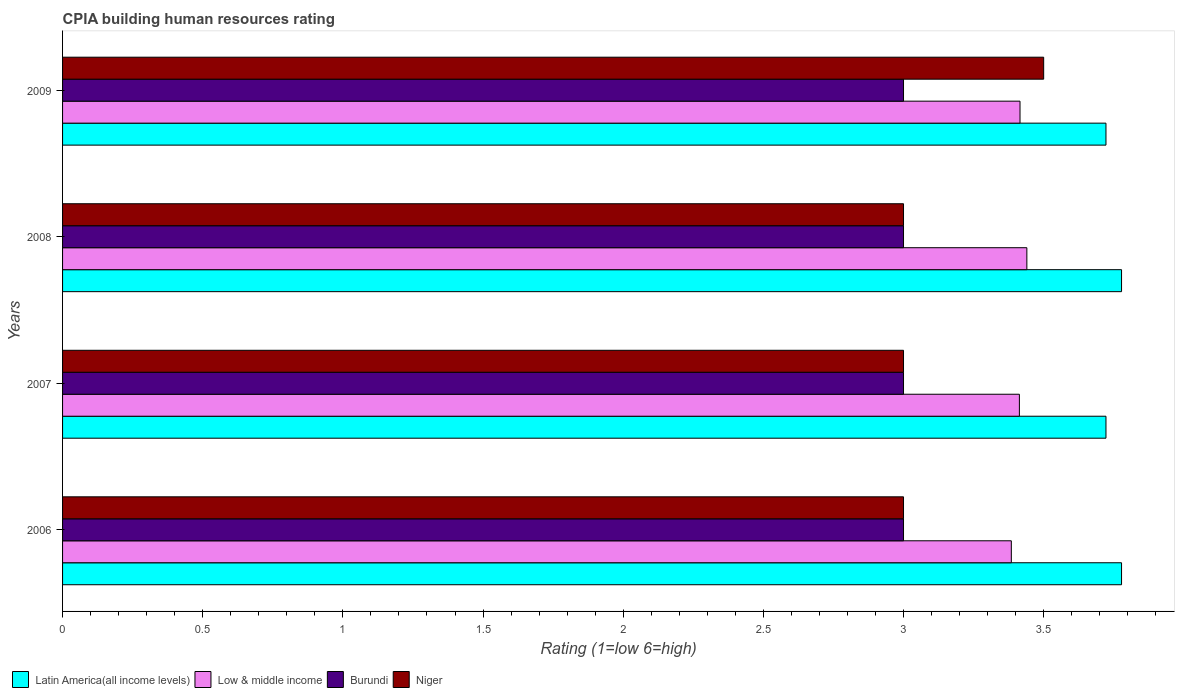Are the number of bars per tick equal to the number of legend labels?
Keep it short and to the point. Yes. What is the CPIA rating in Latin America(all income levels) in 2008?
Keep it short and to the point. 3.78. Across all years, what is the maximum CPIA rating in Low & middle income?
Provide a short and direct response. 3.44. Across all years, what is the minimum CPIA rating in Niger?
Your answer should be very brief. 3. What is the total CPIA rating in Burundi in the graph?
Offer a very short reply. 12. What is the difference between the CPIA rating in Burundi in 2006 and that in 2007?
Your answer should be very brief. 0. What is the difference between the CPIA rating in Burundi in 2006 and the CPIA rating in Low & middle income in 2007?
Keep it short and to the point. -0.41. What is the average CPIA rating in Low & middle income per year?
Give a very brief answer. 3.41. In the year 2009, what is the difference between the CPIA rating in Niger and CPIA rating in Latin America(all income levels)?
Provide a short and direct response. -0.22. In how many years, is the CPIA rating in Low & middle income greater than 0.2 ?
Make the answer very short. 4. What is the ratio of the CPIA rating in Burundi in 2006 to that in 2009?
Ensure brevity in your answer.  1. Is the CPIA rating in Latin America(all income levels) in 2007 less than that in 2009?
Your response must be concise. No. What is the difference between the highest and the second highest CPIA rating in Low & middle income?
Offer a terse response. 0.02. In how many years, is the CPIA rating in Latin America(all income levels) greater than the average CPIA rating in Latin America(all income levels) taken over all years?
Your answer should be very brief. 2. Is it the case that in every year, the sum of the CPIA rating in Latin America(all income levels) and CPIA rating in Burundi is greater than the sum of CPIA rating in Niger and CPIA rating in Low & middle income?
Your answer should be very brief. No. What does the 2nd bar from the top in 2009 represents?
Offer a terse response. Burundi. What does the 3rd bar from the bottom in 2008 represents?
Offer a terse response. Burundi. Is it the case that in every year, the sum of the CPIA rating in Latin America(all income levels) and CPIA rating in Low & middle income is greater than the CPIA rating in Niger?
Provide a succinct answer. Yes. How many bars are there?
Make the answer very short. 16. Are all the bars in the graph horizontal?
Offer a very short reply. Yes. What is the difference between two consecutive major ticks on the X-axis?
Ensure brevity in your answer.  0.5. Does the graph contain any zero values?
Keep it short and to the point. No. How many legend labels are there?
Offer a terse response. 4. How are the legend labels stacked?
Give a very brief answer. Horizontal. What is the title of the graph?
Give a very brief answer. CPIA building human resources rating. What is the label or title of the Y-axis?
Provide a short and direct response. Years. What is the Rating (1=low 6=high) of Latin America(all income levels) in 2006?
Provide a short and direct response. 3.78. What is the Rating (1=low 6=high) of Low & middle income in 2006?
Your answer should be compact. 3.38. What is the Rating (1=low 6=high) of Latin America(all income levels) in 2007?
Offer a terse response. 3.72. What is the Rating (1=low 6=high) of Low & middle income in 2007?
Provide a succinct answer. 3.41. What is the Rating (1=low 6=high) of Burundi in 2007?
Your answer should be compact. 3. What is the Rating (1=low 6=high) in Latin America(all income levels) in 2008?
Offer a very short reply. 3.78. What is the Rating (1=low 6=high) in Low & middle income in 2008?
Give a very brief answer. 3.44. What is the Rating (1=low 6=high) in Niger in 2008?
Your answer should be compact. 3. What is the Rating (1=low 6=high) of Latin America(all income levels) in 2009?
Offer a very short reply. 3.72. What is the Rating (1=low 6=high) of Low & middle income in 2009?
Ensure brevity in your answer.  3.42. What is the Rating (1=low 6=high) of Burundi in 2009?
Offer a terse response. 3. Across all years, what is the maximum Rating (1=low 6=high) of Latin America(all income levels)?
Offer a very short reply. 3.78. Across all years, what is the maximum Rating (1=low 6=high) of Low & middle income?
Your answer should be very brief. 3.44. Across all years, what is the maximum Rating (1=low 6=high) in Burundi?
Make the answer very short. 3. Across all years, what is the maximum Rating (1=low 6=high) of Niger?
Offer a very short reply. 3.5. Across all years, what is the minimum Rating (1=low 6=high) in Latin America(all income levels)?
Provide a short and direct response. 3.72. Across all years, what is the minimum Rating (1=low 6=high) in Low & middle income?
Offer a terse response. 3.38. Across all years, what is the minimum Rating (1=low 6=high) of Burundi?
Provide a succinct answer. 3. Across all years, what is the minimum Rating (1=low 6=high) in Niger?
Make the answer very short. 3. What is the total Rating (1=low 6=high) in Low & middle income in the graph?
Provide a short and direct response. 13.65. What is the total Rating (1=low 6=high) in Burundi in the graph?
Offer a very short reply. 12. What is the total Rating (1=low 6=high) of Niger in the graph?
Give a very brief answer. 12.5. What is the difference between the Rating (1=low 6=high) in Latin America(all income levels) in 2006 and that in 2007?
Provide a short and direct response. 0.06. What is the difference between the Rating (1=low 6=high) of Low & middle income in 2006 and that in 2007?
Your answer should be very brief. -0.03. What is the difference between the Rating (1=low 6=high) of Burundi in 2006 and that in 2007?
Ensure brevity in your answer.  0. What is the difference between the Rating (1=low 6=high) in Latin America(all income levels) in 2006 and that in 2008?
Your answer should be compact. 0. What is the difference between the Rating (1=low 6=high) in Low & middle income in 2006 and that in 2008?
Provide a succinct answer. -0.06. What is the difference between the Rating (1=low 6=high) in Burundi in 2006 and that in 2008?
Offer a very short reply. 0. What is the difference between the Rating (1=low 6=high) of Niger in 2006 and that in 2008?
Give a very brief answer. 0. What is the difference between the Rating (1=low 6=high) of Latin America(all income levels) in 2006 and that in 2009?
Offer a very short reply. 0.06. What is the difference between the Rating (1=low 6=high) of Low & middle income in 2006 and that in 2009?
Keep it short and to the point. -0.03. What is the difference between the Rating (1=low 6=high) of Burundi in 2006 and that in 2009?
Ensure brevity in your answer.  0. What is the difference between the Rating (1=low 6=high) in Latin America(all income levels) in 2007 and that in 2008?
Your response must be concise. -0.06. What is the difference between the Rating (1=low 6=high) in Low & middle income in 2007 and that in 2008?
Provide a succinct answer. -0.03. What is the difference between the Rating (1=low 6=high) of Niger in 2007 and that in 2008?
Ensure brevity in your answer.  0. What is the difference between the Rating (1=low 6=high) in Latin America(all income levels) in 2007 and that in 2009?
Provide a succinct answer. 0. What is the difference between the Rating (1=low 6=high) of Low & middle income in 2007 and that in 2009?
Your response must be concise. -0. What is the difference between the Rating (1=low 6=high) of Niger in 2007 and that in 2009?
Offer a terse response. -0.5. What is the difference between the Rating (1=low 6=high) in Latin America(all income levels) in 2008 and that in 2009?
Provide a succinct answer. 0.06. What is the difference between the Rating (1=low 6=high) of Low & middle income in 2008 and that in 2009?
Your response must be concise. 0.02. What is the difference between the Rating (1=low 6=high) of Latin America(all income levels) in 2006 and the Rating (1=low 6=high) of Low & middle income in 2007?
Give a very brief answer. 0.36. What is the difference between the Rating (1=low 6=high) in Latin America(all income levels) in 2006 and the Rating (1=low 6=high) in Burundi in 2007?
Ensure brevity in your answer.  0.78. What is the difference between the Rating (1=low 6=high) in Low & middle income in 2006 and the Rating (1=low 6=high) in Burundi in 2007?
Provide a succinct answer. 0.38. What is the difference between the Rating (1=low 6=high) in Low & middle income in 2006 and the Rating (1=low 6=high) in Niger in 2007?
Your answer should be very brief. 0.38. What is the difference between the Rating (1=low 6=high) of Burundi in 2006 and the Rating (1=low 6=high) of Niger in 2007?
Ensure brevity in your answer.  0. What is the difference between the Rating (1=low 6=high) of Latin America(all income levels) in 2006 and the Rating (1=low 6=high) of Low & middle income in 2008?
Ensure brevity in your answer.  0.34. What is the difference between the Rating (1=low 6=high) of Low & middle income in 2006 and the Rating (1=low 6=high) of Burundi in 2008?
Provide a succinct answer. 0.38. What is the difference between the Rating (1=low 6=high) of Low & middle income in 2006 and the Rating (1=low 6=high) of Niger in 2008?
Your answer should be very brief. 0.38. What is the difference between the Rating (1=low 6=high) in Burundi in 2006 and the Rating (1=low 6=high) in Niger in 2008?
Provide a succinct answer. 0. What is the difference between the Rating (1=low 6=high) in Latin America(all income levels) in 2006 and the Rating (1=low 6=high) in Low & middle income in 2009?
Ensure brevity in your answer.  0.36. What is the difference between the Rating (1=low 6=high) in Latin America(all income levels) in 2006 and the Rating (1=low 6=high) in Burundi in 2009?
Your answer should be very brief. 0.78. What is the difference between the Rating (1=low 6=high) of Latin America(all income levels) in 2006 and the Rating (1=low 6=high) of Niger in 2009?
Provide a short and direct response. 0.28. What is the difference between the Rating (1=low 6=high) in Low & middle income in 2006 and the Rating (1=low 6=high) in Burundi in 2009?
Offer a very short reply. 0.38. What is the difference between the Rating (1=low 6=high) of Low & middle income in 2006 and the Rating (1=low 6=high) of Niger in 2009?
Give a very brief answer. -0.12. What is the difference between the Rating (1=low 6=high) in Latin America(all income levels) in 2007 and the Rating (1=low 6=high) in Low & middle income in 2008?
Your response must be concise. 0.28. What is the difference between the Rating (1=low 6=high) in Latin America(all income levels) in 2007 and the Rating (1=low 6=high) in Burundi in 2008?
Offer a terse response. 0.72. What is the difference between the Rating (1=low 6=high) of Latin America(all income levels) in 2007 and the Rating (1=low 6=high) of Niger in 2008?
Provide a short and direct response. 0.72. What is the difference between the Rating (1=low 6=high) of Low & middle income in 2007 and the Rating (1=low 6=high) of Burundi in 2008?
Keep it short and to the point. 0.41. What is the difference between the Rating (1=low 6=high) of Low & middle income in 2007 and the Rating (1=low 6=high) of Niger in 2008?
Offer a very short reply. 0.41. What is the difference between the Rating (1=low 6=high) of Latin America(all income levels) in 2007 and the Rating (1=low 6=high) of Low & middle income in 2009?
Provide a short and direct response. 0.31. What is the difference between the Rating (1=low 6=high) in Latin America(all income levels) in 2007 and the Rating (1=low 6=high) in Burundi in 2009?
Ensure brevity in your answer.  0.72. What is the difference between the Rating (1=low 6=high) of Latin America(all income levels) in 2007 and the Rating (1=low 6=high) of Niger in 2009?
Your answer should be compact. 0.22. What is the difference between the Rating (1=low 6=high) in Low & middle income in 2007 and the Rating (1=low 6=high) in Burundi in 2009?
Your answer should be very brief. 0.41. What is the difference between the Rating (1=low 6=high) in Low & middle income in 2007 and the Rating (1=low 6=high) in Niger in 2009?
Your response must be concise. -0.09. What is the difference between the Rating (1=low 6=high) of Burundi in 2007 and the Rating (1=low 6=high) of Niger in 2009?
Offer a very short reply. -0.5. What is the difference between the Rating (1=low 6=high) of Latin America(all income levels) in 2008 and the Rating (1=low 6=high) of Low & middle income in 2009?
Ensure brevity in your answer.  0.36. What is the difference between the Rating (1=low 6=high) in Latin America(all income levels) in 2008 and the Rating (1=low 6=high) in Burundi in 2009?
Ensure brevity in your answer.  0.78. What is the difference between the Rating (1=low 6=high) in Latin America(all income levels) in 2008 and the Rating (1=low 6=high) in Niger in 2009?
Keep it short and to the point. 0.28. What is the difference between the Rating (1=low 6=high) in Low & middle income in 2008 and the Rating (1=low 6=high) in Burundi in 2009?
Your response must be concise. 0.44. What is the difference between the Rating (1=low 6=high) in Low & middle income in 2008 and the Rating (1=low 6=high) in Niger in 2009?
Offer a very short reply. -0.06. What is the average Rating (1=low 6=high) in Latin America(all income levels) per year?
Ensure brevity in your answer.  3.75. What is the average Rating (1=low 6=high) of Low & middle income per year?
Your answer should be very brief. 3.41. What is the average Rating (1=low 6=high) of Niger per year?
Make the answer very short. 3.12. In the year 2006, what is the difference between the Rating (1=low 6=high) in Latin America(all income levels) and Rating (1=low 6=high) in Low & middle income?
Keep it short and to the point. 0.39. In the year 2006, what is the difference between the Rating (1=low 6=high) of Latin America(all income levels) and Rating (1=low 6=high) of Burundi?
Keep it short and to the point. 0.78. In the year 2006, what is the difference between the Rating (1=low 6=high) of Latin America(all income levels) and Rating (1=low 6=high) of Niger?
Ensure brevity in your answer.  0.78. In the year 2006, what is the difference between the Rating (1=low 6=high) of Low & middle income and Rating (1=low 6=high) of Burundi?
Offer a terse response. 0.38. In the year 2006, what is the difference between the Rating (1=low 6=high) in Low & middle income and Rating (1=low 6=high) in Niger?
Give a very brief answer. 0.38. In the year 2006, what is the difference between the Rating (1=low 6=high) of Burundi and Rating (1=low 6=high) of Niger?
Provide a short and direct response. 0. In the year 2007, what is the difference between the Rating (1=low 6=high) in Latin America(all income levels) and Rating (1=low 6=high) in Low & middle income?
Give a very brief answer. 0.31. In the year 2007, what is the difference between the Rating (1=low 6=high) in Latin America(all income levels) and Rating (1=low 6=high) in Burundi?
Offer a very short reply. 0.72. In the year 2007, what is the difference between the Rating (1=low 6=high) of Latin America(all income levels) and Rating (1=low 6=high) of Niger?
Your response must be concise. 0.72. In the year 2007, what is the difference between the Rating (1=low 6=high) of Low & middle income and Rating (1=low 6=high) of Burundi?
Keep it short and to the point. 0.41. In the year 2007, what is the difference between the Rating (1=low 6=high) in Low & middle income and Rating (1=low 6=high) in Niger?
Offer a terse response. 0.41. In the year 2008, what is the difference between the Rating (1=low 6=high) in Latin America(all income levels) and Rating (1=low 6=high) in Low & middle income?
Make the answer very short. 0.34. In the year 2008, what is the difference between the Rating (1=low 6=high) of Latin America(all income levels) and Rating (1=low 6=high) of Burundi?
Provide a succinct answer. 0.78. In the year 2008, what is the difference between the Rating (1=low 6=high) of Latin America(all income levels) and Rating (1=low 6=high) of Niger?
Keep it short and to the point. 0.78. In the year 2008, what is the difference between the Rating (1=low 6=high) in Low & middle income and Rating (1=low 6=high) in Burundi?
Ensure brevity in your answer.  0.44. In the year 2008, what is the difference between the Rating (1=low 6=high) of Low & middle income and Rating (1=low 6=high) of Niger?
Provide a short and direct response. 0.44. In the year 2009, what is the difference between the Rating (1=low 6=high) of Latin America(all income levels) and Rating (1=low 6=high) of Low & middle income?
Provide a succinct answer. 0.31. In the year 2009, what is the difference between the Rating (1=low 6=high) of Latin America(all income levels) and Rating (1=low 6=high) of Burundi?
Provide a short and direct response. 0.72. In the year 2009, what is the difference between the Rating (1=low 6=high) of Latin America(all income levels) and Rating (1=low 6=high) of Niger?
Your response must be concise. 0.22. In the year 2009, what is the difference between the Rating (1=low 6=high) in Low & middle income and Rating (1=low 6=high) in Burundi?
Your answer should be very brief. 0.42. In the year 2009, what is the difference between the Rating (1=low 6=high) of Low & middle income and Rating (1=low 6=high) of Niger?
Make the answer very short. -0.08. What is the ratio of the Rating (1=low 6=high) in Latin America(all income levels) in 2006 to that in 2007?
Ensure brevity in your answer.  1.01. What is the ratio of the Rating (1=low 6=high) in Low & middle income in 2006 to that in 2007?
Ensure brevity in your answer.  0.99. What is the ratio of the Rating (1=low 6=high) in Burundi in 2006 to that in 2007?
Make the answer very short. 1. What is the ratio of the Rating (1=low 6=high) of Niger in 2006 to that in 2007?
Make the answer very short. 1. What is the ratio of the Rating (1=low 6=high) of Latin America(all income levels) in 2006 to that in 2008?
Offer a terse response. 1. What is the ratio of the Rating (1=low 6=high) in Low & middle income in 2006 to that in 2008?
Your answer should be compact. 0.98. What is the ratio of the Rating (1=low 6=high) in Latin America(all income levels) in 2006 to that in 2009?
Your answer should be compact. 1.01. What is the ratio of the Rating (1=low 6=high) of Low & middle income in 2006 to that in 2009?
Make the answer very short. 0.99. What is the ratio of the Rating (1=low 6=high) of Burundi in 2006 to that in 2009?
Your response must be concise. 1. What is the ratio of the Rating (1=low 6=high) in Niger in 2006 to that in 2009?
Give a very brief answer. 0.86. What is the ratio of the Rating (1=low 6=high) of Latin America(all income levels) in 2007 to that in 2008?
Offer a terse response. 0.99. What is the ratio of the Rating (1=low 6=high) of Burundi in 2007 to that in 2008?
Your response must be concise. 1. What is the ratio of the Rating (1=low 6=high) in Burundi in 2007 to that in 2009?
Your answer should be compact. 1. What is the ratio of the Rating (1=low 6=high) of Latin America(all income levels) in 2008 to that in 2009?
Make the answer very short. 1.01. What is the ratio of the Rating (1=low 6=high) of Low & middle income in 2008 to that in 2009?
Ensure brevity in your answer.  1.01. What is the ratio of the Rating (1=low 6=high) in Niger in 2008 to that in 2009?
Give a very brief answer. 0.86. What is the difference between the highest and the second highest Rating (1=low 6=high) in Latin America(all income levels)?
Your answer should be very brief. 0. What is the difference between the highest and the second highest Rating (1=low 6=high) of Low & middle income?
Give a very brief answer. 0.02. What is the difference between the highest and the second highest Rating (1=low 6=high) of Burundi?
Offer a terse response. 0. What is the difference between the highest and the lowest Rating (1=low 6=high) of Latin America(all income levels)?
Ensure brevity in your answer.  0.06. What is the difference between the highest and the lowest Rating (1=low 6=high) of Low & middle income?
Offer a terse response. 0.06. 